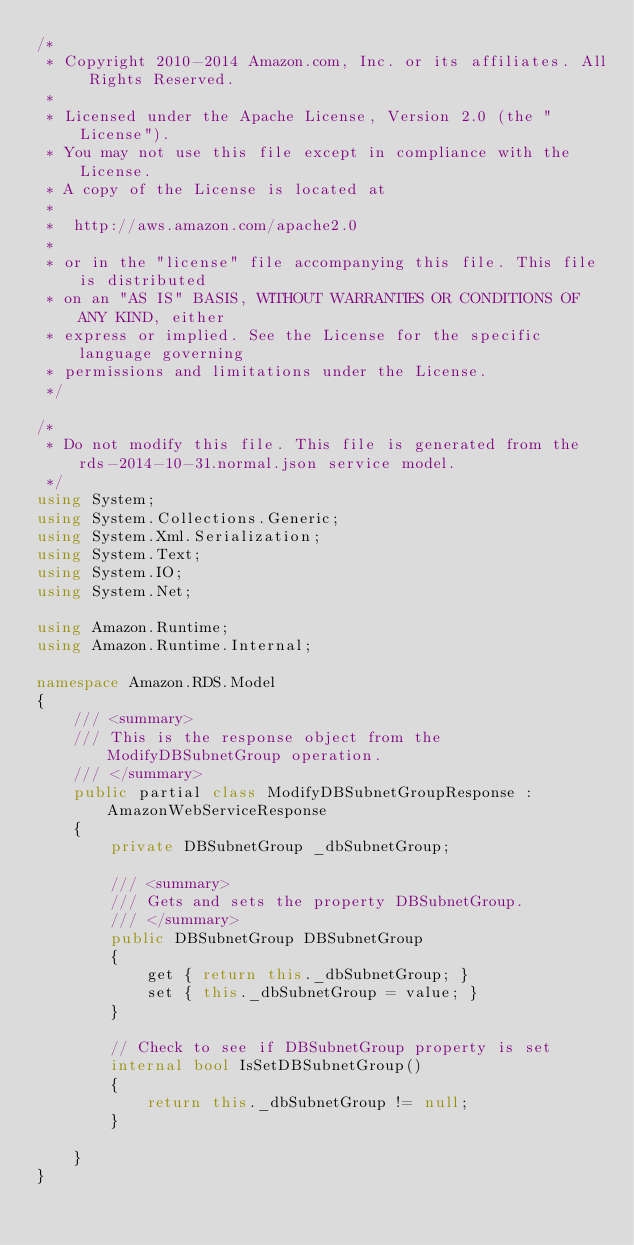Convert code to text. <code><loc_0><loc_0><loc_500><loc_500><_C#_>/*
 * Copyright 2010-2014 Amazon.com, Inc. or its affiliates. All Rights Reserved.
 * 
 * Licensed under the Apache License, Version 2.0 (the "License").
 * You may not use this file except in compliance with the License.
 * A copy of the License is located at
 * 
 *  http://aws.amazon.com/apache2.0
 * 
 * or in the "license" file accompanying this file. This file is distributed
 * on an "AS IS" BASIS, WITHOUT WARRANTIES OR CONDITIONS OF ANY KIND, either
 * express or implied. See the License for the specific language governing
 * permissions and limitations under the License.
 */

/*
 * Do not modify this file. This file is generated from the rds-2014-10-31.normal.json service model.
 */
using System;
using System.Collections.Generic;
using System.Xml.Serialization;
using System.Text;
using System.IO;
using System.Net;

using Amazon.Runtime;
using Amazon.Runtime.Internal;

namespace Amazon.RDS.Model
{
    /// <summary>
    /// This is the response object from the ModifyDBSubnetGroup operation.
    /// </summary>
    public partial class ModifyDBSubnetGroupResponse : AmazonWebServiceResponse
    {
        private DBSubnetGroup _dbSubnetGroup;

        /// <summary>
        /// Gets and sets the property DBSubnetGroup.
        /// </summary>
        public DBSubnetGroup DBSubnetGroup
        {
            get { return this._dbSubnetGroup; }
            set { this._dbSubnetGroup = value; }
        }

        // Check to see if DBSubnetGroup property is set
        internal bool IsSetDBSubnetGroup()
        {
            return this._dbSubnetGroup != null;
        }

    }
}</code> 